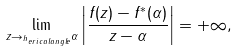<formula> <loc_0><loc_0><loc_500><loc_500>\lim _ { z \rightarrow _ { ^ { h } e r i c a l a n g l e } \alpha } \left | \frac { f ( z ) - f ^ { * } ( \alpha ) } { z - \alpha } \right | = + \infty ,</formula> 